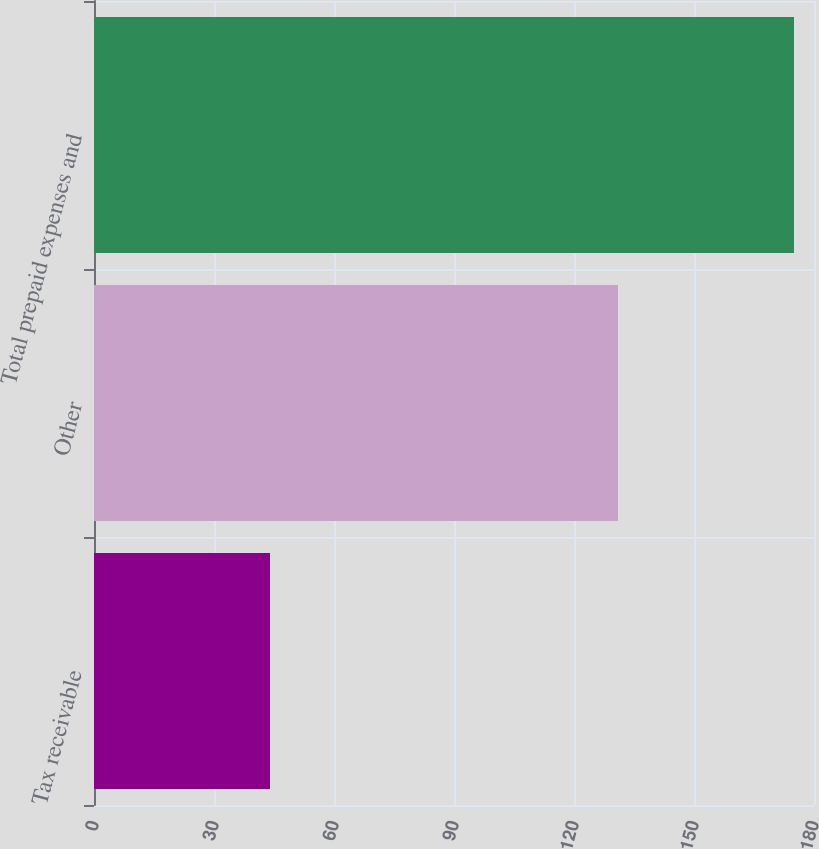Convert chart to OTSL. <chart><loc_0><loc_0><loc_500><loc_500><bar_chart><fcel>Tax receivable<fcel>Other<fcel>Total prepaid expenses and<nl><fcel>44<fcel>131<fcel>175<nl></chart> 